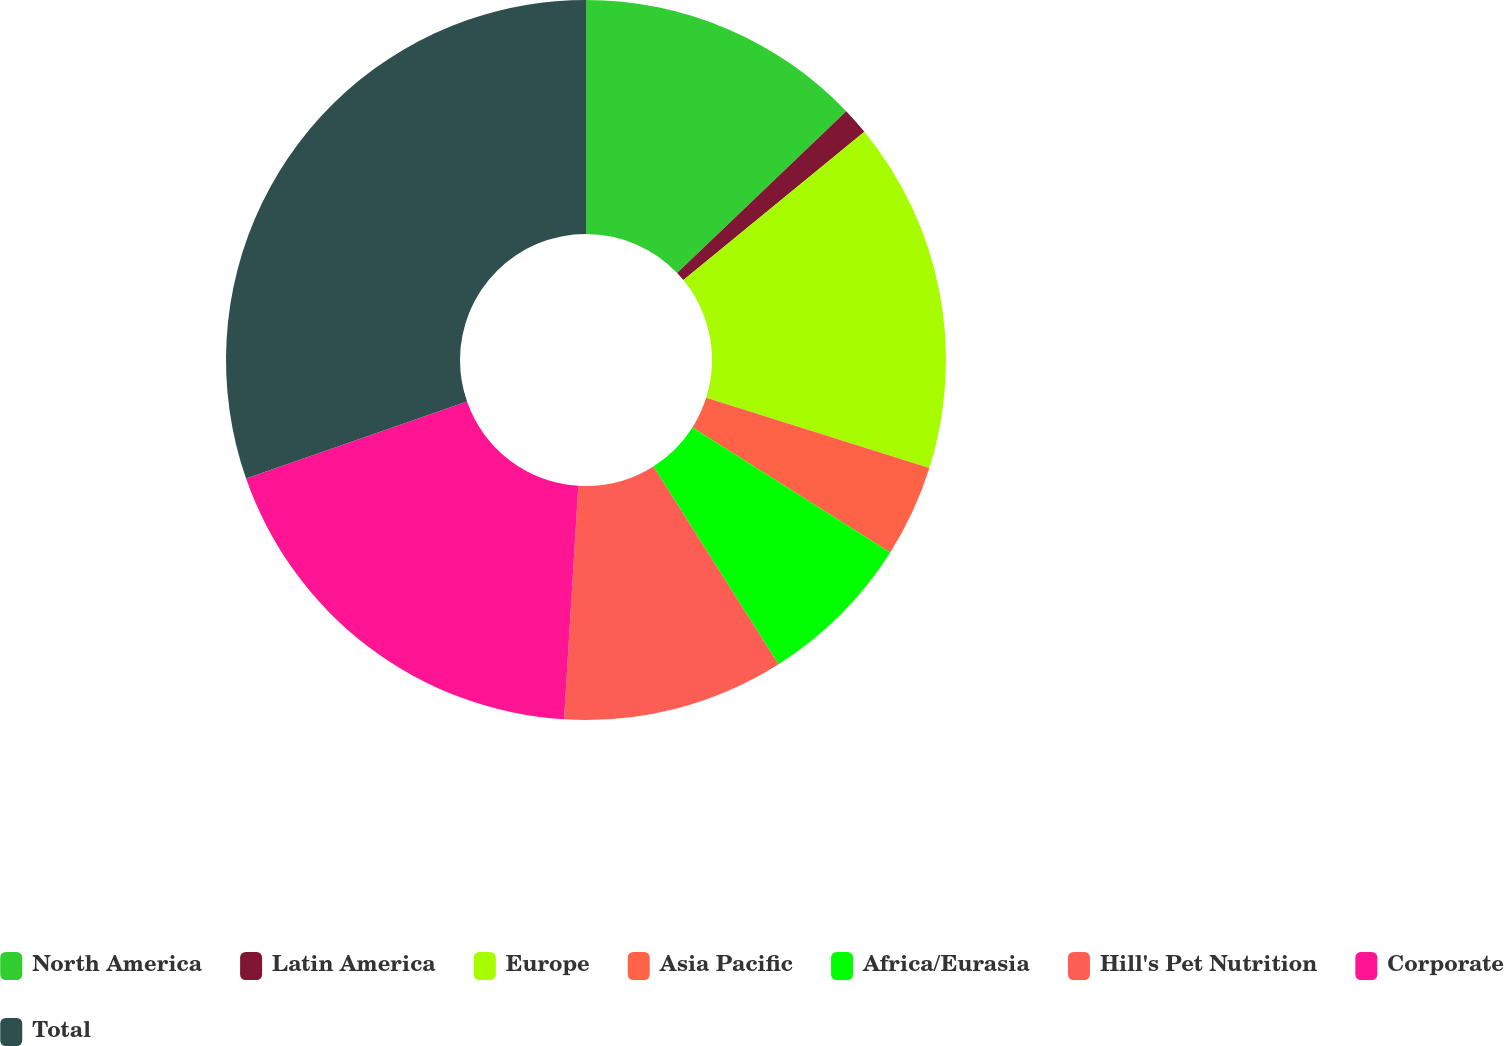<chart> <loc_0><loc_0><loc_500><loc_500><pie_chart><fcel>North America<fcel>Latin America<fcel>Europe<fcel>Asia Pacific<fcel>Africa/Eurasia<fcel>Hill's Pet Nutrition<fcel>Corporate<fcel>Total<nl><fcel>12.86%<fcel>1.21%<fcel>15.78%<fcel>4.13%<fcel>7.04%<fcel>9.95%<fcel>18.69%<fcel>30.34%<nl></chart> 